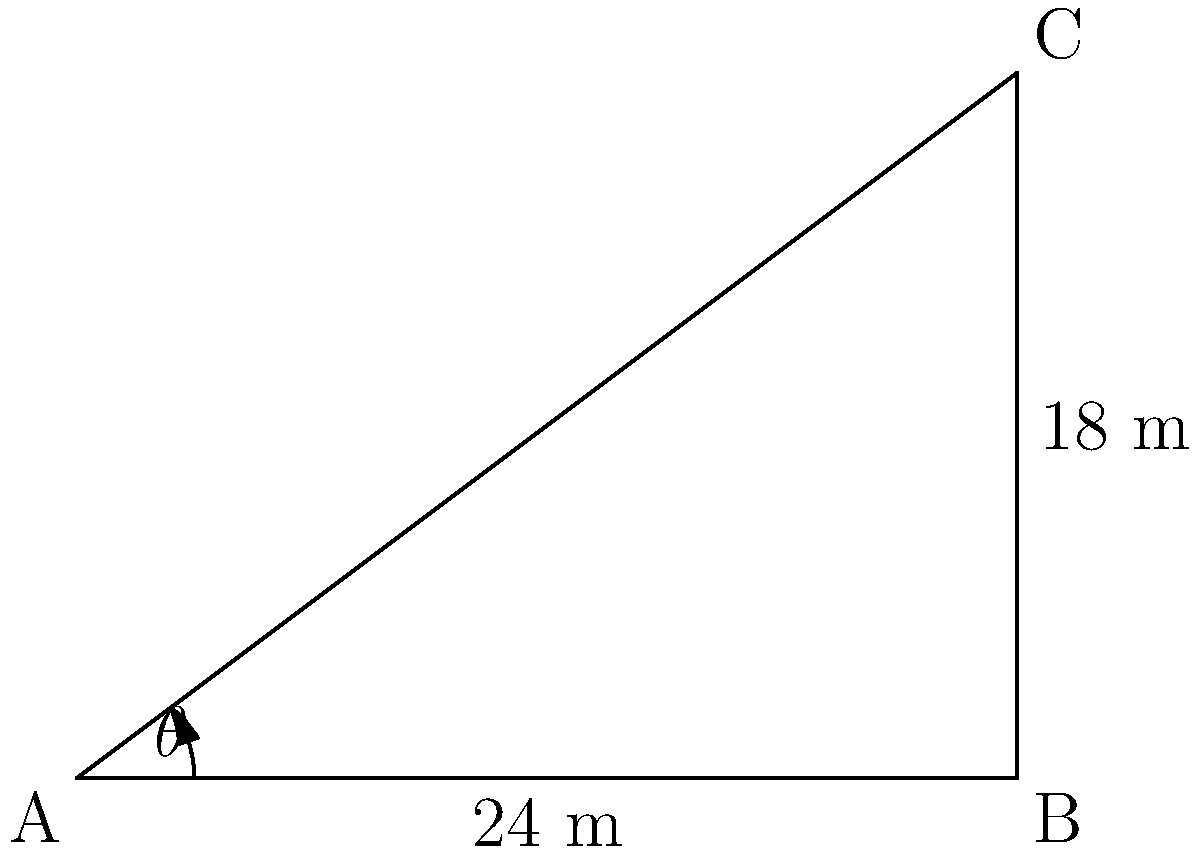In a K League 1 match, a player is preparing to take a corner kick. The corner flag is at point A, the near goalpost is at point B, and the far goalpost is at point C. The distance between the goalposts (BC) is 18 meters, and the distance from the corner flag to the near goalpost (AB) is 24 meters. What is the angle θ of the corner kick needed to aim directly at the far goalpost? Let's solve this step-by-step using trigonometry:

1) First, we need to identify the right triangle in this problem. Triangle ABC is a right triangle, with the right angle at B.

2) We're looking for angle θ at A. This is opposite to side BC and adjacent to side AB.

3) In a right triangle, when we know the opposite and adjacent sides to an angle, we use the tangent function:

   $\tan \theta = \frac{\text{opposite}}{\text{adjacent}}$

4) In this case:
   $\tan \theta = \frac{BC}{AB} = \frac{18}{24} = \frac{3}{4} = 0.75$

5) To find θ, we need to use the inverse tangent (arctan or $\tan^{-1}$):

   $\theta = \tan^{-1}(0.75)$

6) Using a calculator or trigonometric tables:

   $\theta \approx 36.87°$

Therefore, the player needs to kick the ball at an angle of approximately 36.87° to aim directly at the far goalpost.
Answer: $36.87°$ 